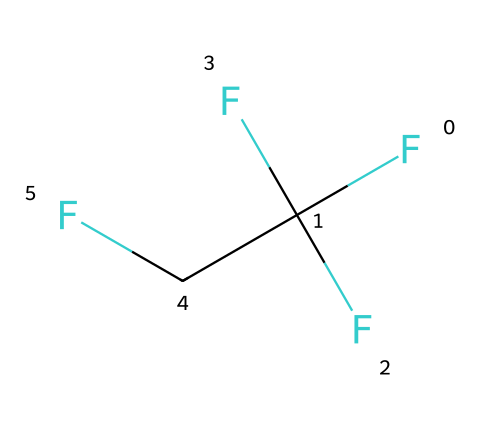What is the common name of the refrigerant with this structure? The SMILES representation corresponds to a refrigerant known as R-134a. This is a widely used refrigerant in automotive air conditioning systems.
Answer: R-134a How many carbon atoms are present in R-134a? By analyzing the SMILES, we see one carbon atom in 'F', and the 'C' indicates the presence of carbon atoms. The full structure features two carbon atoms within the chain, thus totaling two.
Answer: 2 What is the total number of fluorine atoms in this chemical? The SMILES representation includes 'F' three times, indicating that there are three fluorine atoms attached to the carbon chain.
Answer: 3 What type of bonds are likely present in R-134a? In R-134a, we have carbon-carbon single bonds and carbon-fluorine single bonds. The SMILES notation reflects these types of bonds based on their connections.
Answer: single bonds Is R-134a an organic or inorganic compound? The presence of carbon in its structure classifies R-134a as an organic compound, as it contains carbon atoms in its molecular framework.
Answer: organic What is the significance of fluorine in the structure of R-134a? Fluorine atoms in R-134a enhance its thermodynamic properties, stability, and low environmental impact compared to other refrigerants, making it suitable for air conditioning.
Answer: thermodynamic properties 